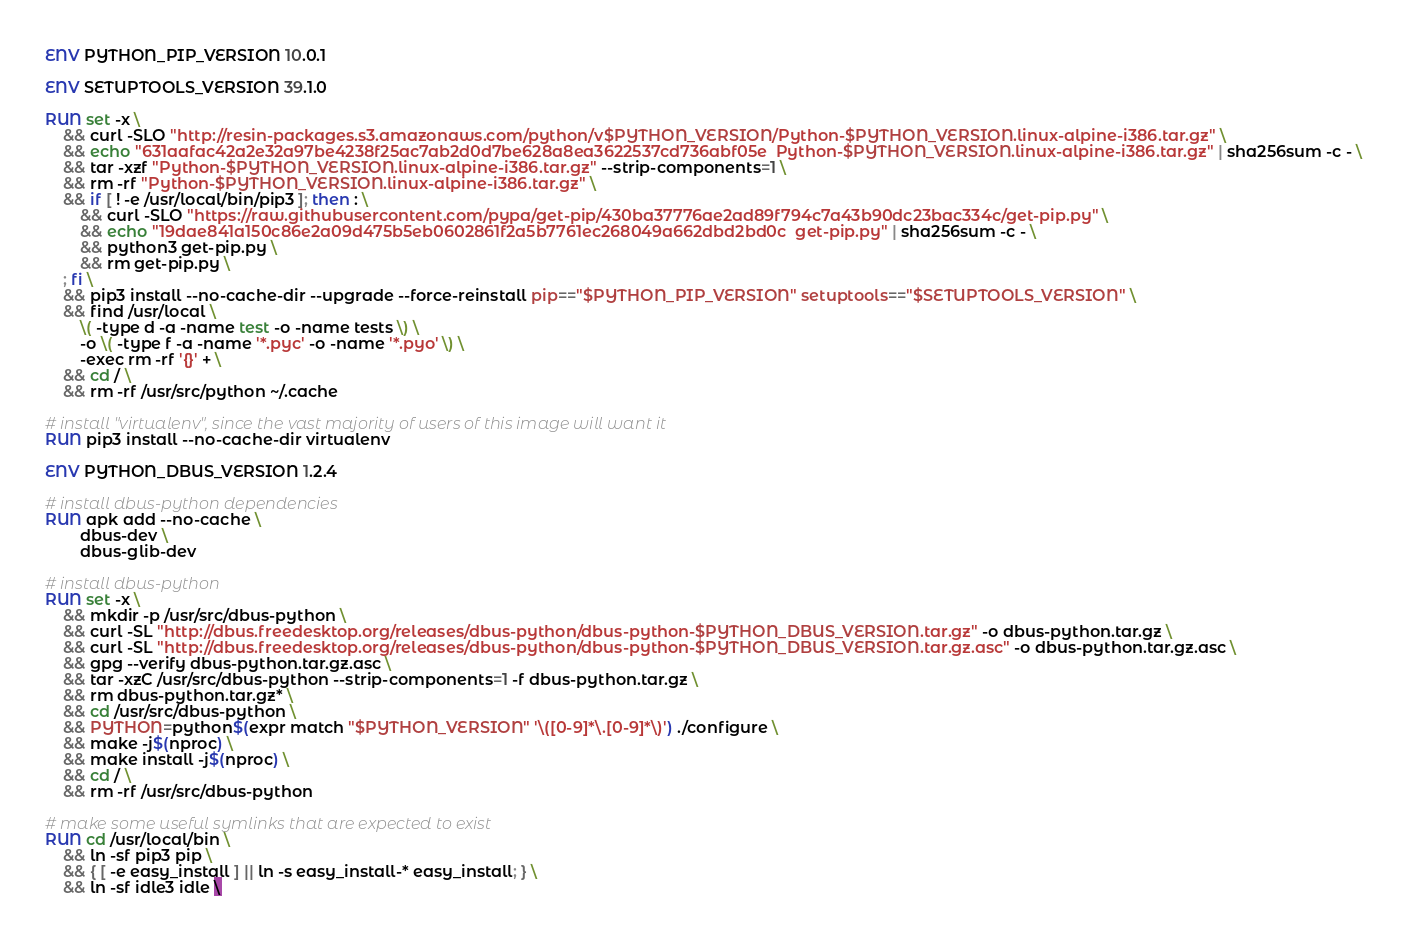Convert code to text. <code><loc_0><loc_0><loc_500><loc_500><_Dockerfile_>ENV PYTHON_PIP_VERSION 10.0.1

ENV SETUPTOOLS_VERSION 39.1.0

RUN set -x \
	&& curl -SLO "http://resin-packages.s3.amazonaws.com/python/v$PYTHON_VERSION/Python-$PYTHON_VERSION.linux-alpine-i386.tar.gz" \
	&& echo "631aafac42a2e32a97be4238f25ac7ab2d0d7be628a8ea3622537cd736abf05e  Python-$PYTHON_VERSION.linux-alpine-i386.tar.gz" | sha256sum -c - \
	&& tar -xzf "Python-$PYTHON_VERSION.linux-alpine-i386.tar.gz" --strip-components=1 \
	&& rm -rf "Python-$PYTHON_VERSION.linux-alpine-i386.tar.gz" \
	&& if [ ! -e /usr/local/bin/pip3 ]; then : \
		&& curl -SLO "https://raw.githubusercontent.com/pypa/get-pip/430ba37776ae2ad89f794c7a43b90dc23bac334c/get-pip.py" \
		&& echo "19dae841a150c86e2a09d475b5eb0602861f2a5b7761ec268049a662dbd2bd0c  get-pip.py" | sha256sum -c - \
		&& python3 get-pip.py \
		&& rm get-pip.py \
	; fi \
	&& pip3 install --no-cache-dir --upgrade --force-reinstall pip=="$PYTHON_PIP_VERSION" setuptools=="$SETUPTOOLS_VERSION" \
	&& find /usr/local \
		\( -type d -a -name test -o -name tests \) \
		-o \( -type f -a -name '*.pyc' -o -name '*.pyo' \) \
		-exec rm -rf '{}' + \
	&& cd / \
	&& rm -rf /usr/src/python ~/.cache

# install "virtualenv", since the vast majority of users of this image will want it
RUN pip3 install --no-cache-dir virtualenv

ENV PYTHON_DBUS_VERSION 1.2.4

# install dbus-python dependencies 
RUN apk add --no-cache \
		dbus-dev \
		dbus-glib-dev

# install dbus-python
RUN set -x \
	&& mkdir -p /usr/src/dbus-python \
	&& curl -SL "http://dbus.freedesktop.org/releases/dbus-python/dbus-python-$PYTHON_DBUS_VERSION.tar.gz" -o dbus-python.tar.gz \
	&& curl -SL "http://dbus.freedesktop.org/releases/dbus-python/dbus-python-$PYTHON_DBUS_VERSION.tar.gz.asc" -o dbus-python.tar.gz.asc \
	&& gpg --verify dbus-python.tar.gz.asc \
	&& tar -xzC /usr/src/dbus-python --strip-components=1 -f dbus-python.tar.gz \
	&& rm dbus-python.tar.gz* \
	&& cd /usr/src/dbus-python \
	&& PYTHON=python$(expr match "$PYTHON_VERSION" '\([0-9]*\.[0-9]*\)') ./configure \
	&& make -j$(nproc) \
	&& make install -j$(nproc) \
	&& cd / \
	&& rm -rf /usr/src/dbus-python

# make some useful symlinks that are expected to exist
RUN cd /usr/local/bin \
	&& ln -sf pip3 pip \
	&& { [ -e easy_install ] || ln -s easy_install-* easy_install; } \
	&& ln -sf idle3 idle \</code> 